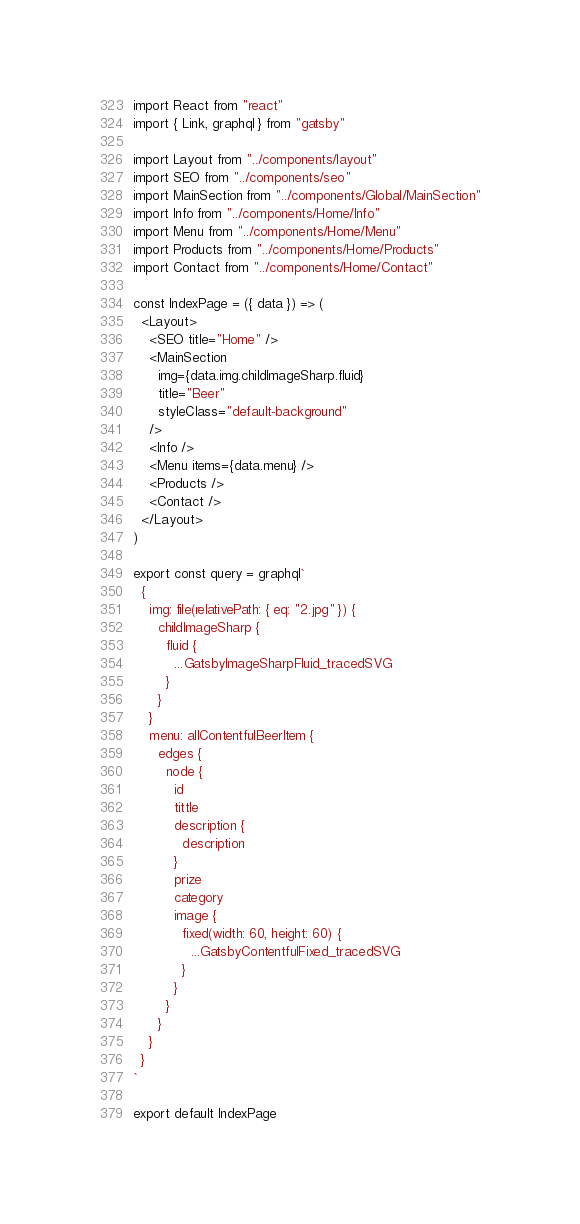Convert code to text. <code><loc_0><loc_0><loc_500><loc_500><_JavaScript_>import React from "react"
import { Link, graphql } from "gatsby"

import Layout from "../components/layout"
import SEO from "../components/seo"
import MainSection from "../components/Global/MainSection"
import Info from "../components/Home/Info"
import Menu from "../components/Home/Menu"
import Products from "../components/Home/Products"
import Contact from "../components/Home/Contact"

const IndexPage = ({ data }) => (
  <Layout>
    <SEO title="Home" />
    <MainSection
      img={data.img.childImageSharp.fluid}
      title="Beer"
      styleClass="default-background"
    />
    <Info />
    <Menu items={data.menu} />
    <Products />
    <Contact />
  </Layout>
)

export const query = graphql`
  {
    img: file(relativePath: { eq: "2.jpg" }) {
      childImageSharp {
        fluid {
          ...GatsbyImageSharpFluid_tracedSVG
        }
      }
    }
    menu: allContentfulBeerItem {
      edges {
        node {
          id
          tittle
          description {
            description
          }
          prize
          category
          image {
            fixed(width: 60, height: 60) {
              ...GatsbyContentfulFixed_tracedSVG
            }
          }
        }
      }
    }
  }
`

export default IndexPage
</code> 